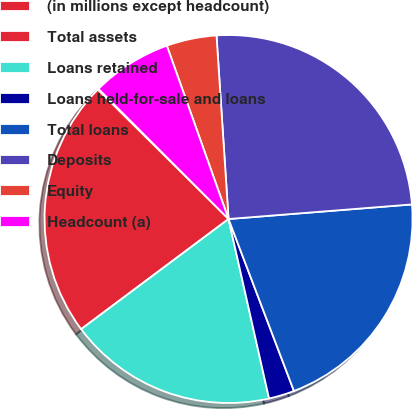Convert chart. <chart><loc_0><loc_0><loc_500><loc_500><pie_chart><fcel>(in millions except headcount)<fcel>Total assets<fcel>Loans retained<fcel>Loans held-for-sale and loans<fcel>Total loans<fcel>Deposits<fcel>Equity<fcel>Headcount (a)<nl><fcel>0.09%<fcel>22.63%<fcel>18.32%<fcel>2.25%<fcel>20.48%<fcel>24.78%<fcel>4.4%<fcel>7.05%<nl></chart> 